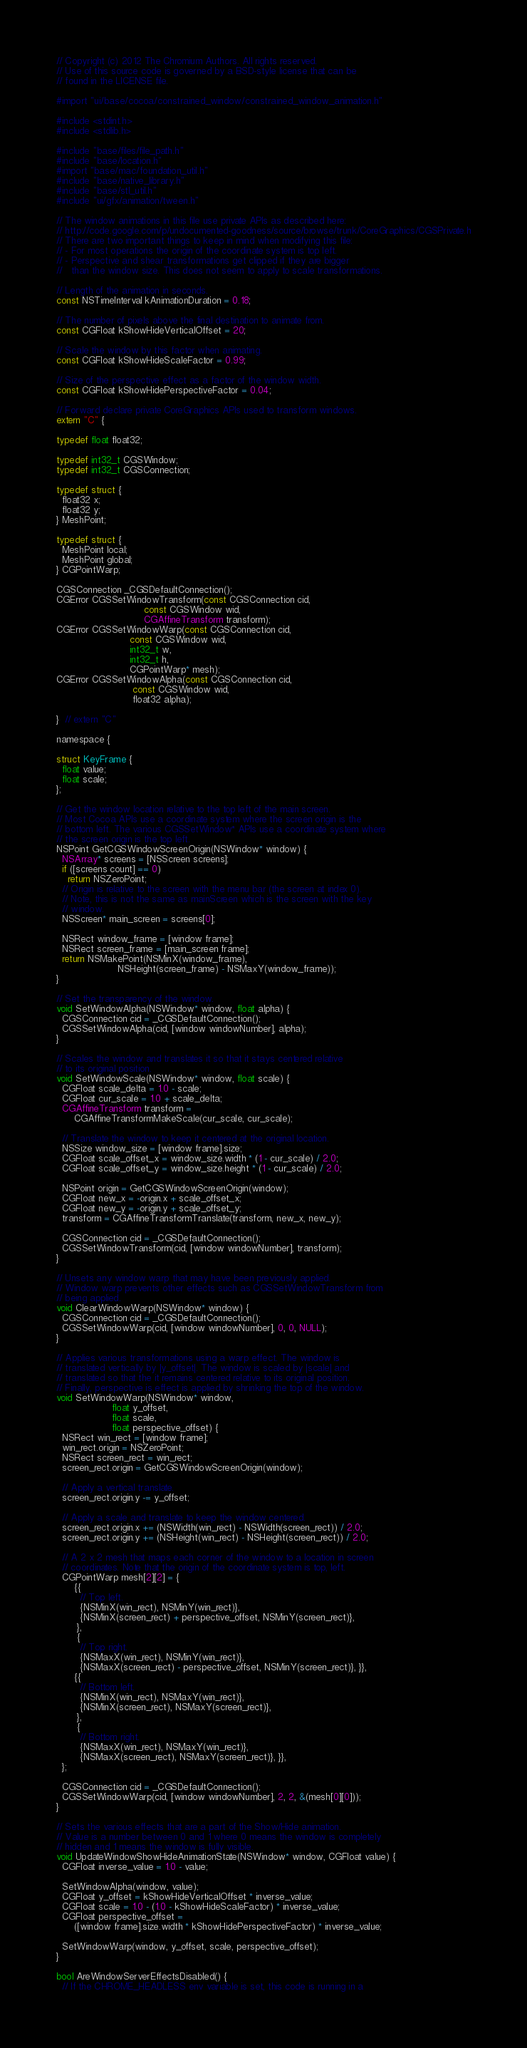<code> <loc_0><loc_0><loc_500><loc_500><_ObjectiveC_>// Copyright (c) 2012 The Chromium Authors. All rights reserved.
// Use of this source code is governed by a BSD-style license that can be
// found in the LICENSE file.

#import "ui/base/cocoa/constrained_window/constrained_window_animation.h"

#include <stdint.h>
#include <stdlib.h>

#include "base/files/file_path.h"
#include "base/location.h"
#import "base/mac/foundation_util.h"
#include "base/native_library.h"
#include "base/stl_util.h"
#include "ui/gfx/animation/tween.h"

// The window animations in this file use private APIs as described here:
// http://code.google.com/p/undocumented-goodness/source/browse/trunk/CoreGraphics/CGSPrivate.h
// There are two important things to keep in mind when modifying this file:
// - For most operations the origin of the coordinate system is top left.
// - Perspective and shear transformations get clipped if they are bigger
//   than the window size. This does not seem to apply to scale transformations.

// Length of the animation in seconds.
const NSTimeInterval kAnimationDuration = 0.18;

// The number of pixels above the final destination to animate from.
const CGFloat kShowHideVerticalOffset = 20;

// Scale the window by this factor when animating.
const CGFloat kShowHideScaleFactor = 0.99;

// Size of the perspective effect as a factor of the window width.
const CGFloat kShowHidePerspectiveFactor = 0.04;

// Forward declare private CoreGraphics APIs used to transform windows.
extern "C" {

typedef float float32;

typedef int32_t CGSWindow;
typedef int32_t CGSConnection;

typedef struct {
  float32 x;
  float32 y;
} MeshPoint;

typedef struct {
  MeshPoint local;
  MeshPoint global;
} CGPointWarp;

CGSConnection _CGSDefaultConnection();
CGError CGSSetWindowTransform(const CGSConnection cid,
                              const CGSWindow wid,
                              CGAffineTransform transform);
CGError CGSSetWindowWarp(const CGSConnection cid,
                         const CGSWindow wid,
                         int32_t w,
                         int32_t h,
                         CGPointWarp* mesh);
CGError CGSSetWindowAlpha(const CGSConnection cid,
                          const CGSWindow wid,
                          float32 alpha);

}  // extern "C"

namespace {

struct KeyFrame {
  float value;
  float scale;
};

// Get the window location relative to the top left of the main screen.
// Most Cocoa APIs use a coordinate system where the screen origin is the
// bottom left. The various CGSSetWindow* APIs use a coordinate system where
// the screen origin is the top left.
NSPoint GetCGSWindowScreenOrigin(NSWindow* window) {
  NSArray* screens = [NSScreen screens];
  if ([screens count] == 0)
    return NSZeroPoint;
  // Origin is relative to the screen with the menu bar (the screen at index 0).
  // Note, this is not the same as mainScreen which is the screen with the key
  // window.
  NSScreen* main_screen = screens[0];

  NSRect window_frame = [window frame];
  NSRect screen_frame = [main_screen frame];
  return NSMakePoint(NSMinX(window_frame),
                     NSHeight(screen_frame) - NSMaxY(window_frame));
}

// Set the transparency of the window.
void SetWindowAlpha(NSWindow* window, float alpha) {
  CGSConnection cid = _CGSDefaultConnection();
  CGSSetWindowAlpha(cid, [window windowNumber], alpha);
}

// Scales the window and translates it so that it stays centered relative
// to its original position.
void SetWindowScale(NSWindow* window, float scale) {
  CGFloat scale_delta = 1.0 - scale;
  CGFloat cur_scale = 1.0 + scale_delta;
  CGAffineTransform transform =
      CGAffineTransformMakeScale(cur_scale, cur_scale);

  // Translate the window to keep it centered at the original location.
  NSSize window_size = [window frame].size;
  CGFloat scale_offset_x = window_size.width * (1 - cur_scale) / 2.0;
  CGFloat scale_offset_y = window_size.height * (1 - cur_scale) / 2.0;

  NSPoint origin = GetCGSWindowScreenOrigin(window);
  CGFloat new_x = -origin.x + scale_offset_x;
  CGFloat new_y = -origin.y + scale_offset_y;
  transform = CGAffineTransformTranslate(transform, new_x, new_y);

  CGSConnection cid = _CGSDefaultConnection();
  CGSSetWindowTransform(cid, [window windowNumber], transform);
}

// Unsets any window warp that may have been previously applied.
// Window warp prevents other effects such as CGSSetWindowTransform from
// being applied.
void ClearWindowWarp(NSWindow* window) {
  CGSConnection cid = _CGSDefaultConnection();
  CGSSetWindowWarp(cid, [window windowNumber], 0, 0, NULL);
}

// Applies various transformations using a warp effect. The window is
// translated vertically by |y_offset|. The window is scaled by |scale| and
// translated so that the it remains centered relative to its original position.
// Finally, perspective is effect is applied by shrinking the top of the window.
void SetWindowWarp(NSWindow* window,
                   float y_offset,
                   float scale,
                   float perspective_offset) {
  NSRect win_rect = [window frame];
  win_rect.origin = NSZeroPoint;
  NSRect screen_rect = win_rect;
  screen_rect.origin = GetCGSWindowScreenOrigin(window);

  // Apply a vertical translate.
  screen_rect.origin.y -= y_offset;

  // Apply a scale and translate to keep the window centered.
  screen_rect.origin.x += (NSWidth(win_rect) - NSWidth(screen_rect)) / 2.0;
  screen_rect.origin.y += (NSHeight(win_rect) - NSHeight(screen_rect)) / 2.0;

  // A 2 x 2 mesh that maps each corner of the window to a location in screen
  // coordinates. Note that the origin of the coordinate system is top, left.
  CGPointWarp mesh[2][2] = {
      {{
        // Top left.
        {NSMinX(win_rect), NSMinY(win_rect)},
        {NSMinX(screen_rect) + perspective_offset, NSMinY(screen_rect)},
       },
       {
        // Top right.
        {NSMaxX(win_rect), NSMinY(win_rect)},
        {NSMaxX(screen_rect) - perspective_offset, NSMinY(screen_rect)}, }},
      {{
        // Bottom left.
        {NSMinX(win_rect), NSMaxY(win_rect)},
        {NSMinX(screen_rect), NSMaxY(screen_rect)},
       },
       {
        // Bottom right.
        {NSMaxX(win_rect), NSMaxY(win_rect)},
        {NSMaxX(screen_rect), NSMaxY(screen_rect)}, }},
  };

  CGSConnection cid = _CGSDefaultConnection();
  CGSSetWindowWarp(cid, [window windowNumber], 2, 2, &(mesh[0][0]));
}

// Sets the various effects that are a part of the Show/Hide animation.
// Value is a number between 0 and 1 where 0 means the window is completely
// hidden and 1 means the window is fully visible.
void UpdateWindowShowHideAnimationState(NSWindow* window, CGFloat value) {
  CGFloat inverse_value = 1.0 - value;

  SetWindowAlpha(window, value);
  CGFloat y_offset = kShowHideVerticalOffset * inverse_value;
  CGFloat scale = 1.0 - (1.0 - kShowHideScaleFactor) * inverse_value;
  CGFloat perspective_offset =
      ([window frame].size.width * kShowHidePerspectiveFactor) * inverse_value;

  SetWindowWarp(window, y_offset, scale, perspective_offset);
}

bool AreWindowServerEffectsDisabled() {
  // If the CHROME_HEADLESS env variable is set, this code is running in a</code> 